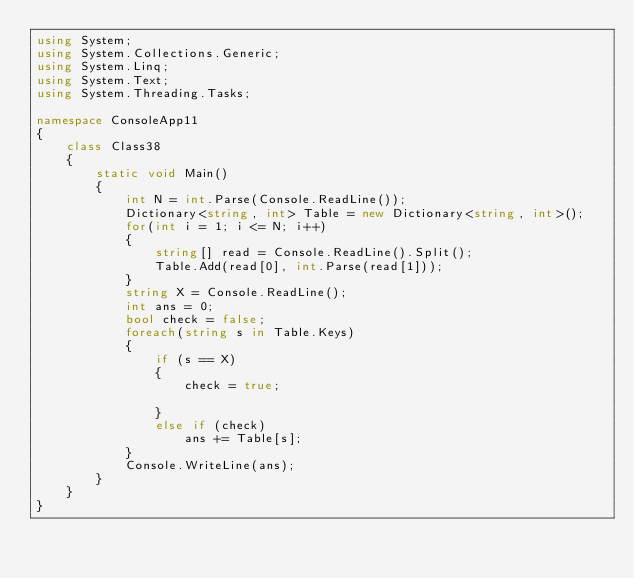<code> <loc_0><loc_0><loc_500><loc_500><_C#_>using System;
using System.Collections.Generic;
using System.Linq;
using System.Text;
using System.Threading.Tasks;

namespace ConsoleApp11
{
    class Class38
    {
        static void Main()
        {
            int N = int.Parse(Console.ReadLine());
            Dictionary<string, int> Table = new Dictionary<string, int>();
            for(int i = 1; i <= N; i++)
            {
                string[] read = Console.ReadLine().Split();
                Table.Add(read[0], int.Parse(read[1]));
            }
            string X = Console.ReadLine();
            int ans = 0;
            bool check = false;
            foreach(string s in Table.Keys)
            {
                if (s == X)
                {
                    check = true;

                }
                else if (check)
                    ans += Table[s];
            }
            Console.WriteLine(ans);
        }
    }
}
</code> 